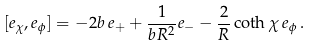<formula> <loc_0><loc_0><loc_500><loc_500>[ e _ { \chi } , e _ { \phi } ] = - 2 b \, e _ { + } + \frac { 1 } { b R ^ { 2 } } e _ { - } - \frac { 2 } { R } \coth \chi \, e _ { \phi } \, .</formula> 